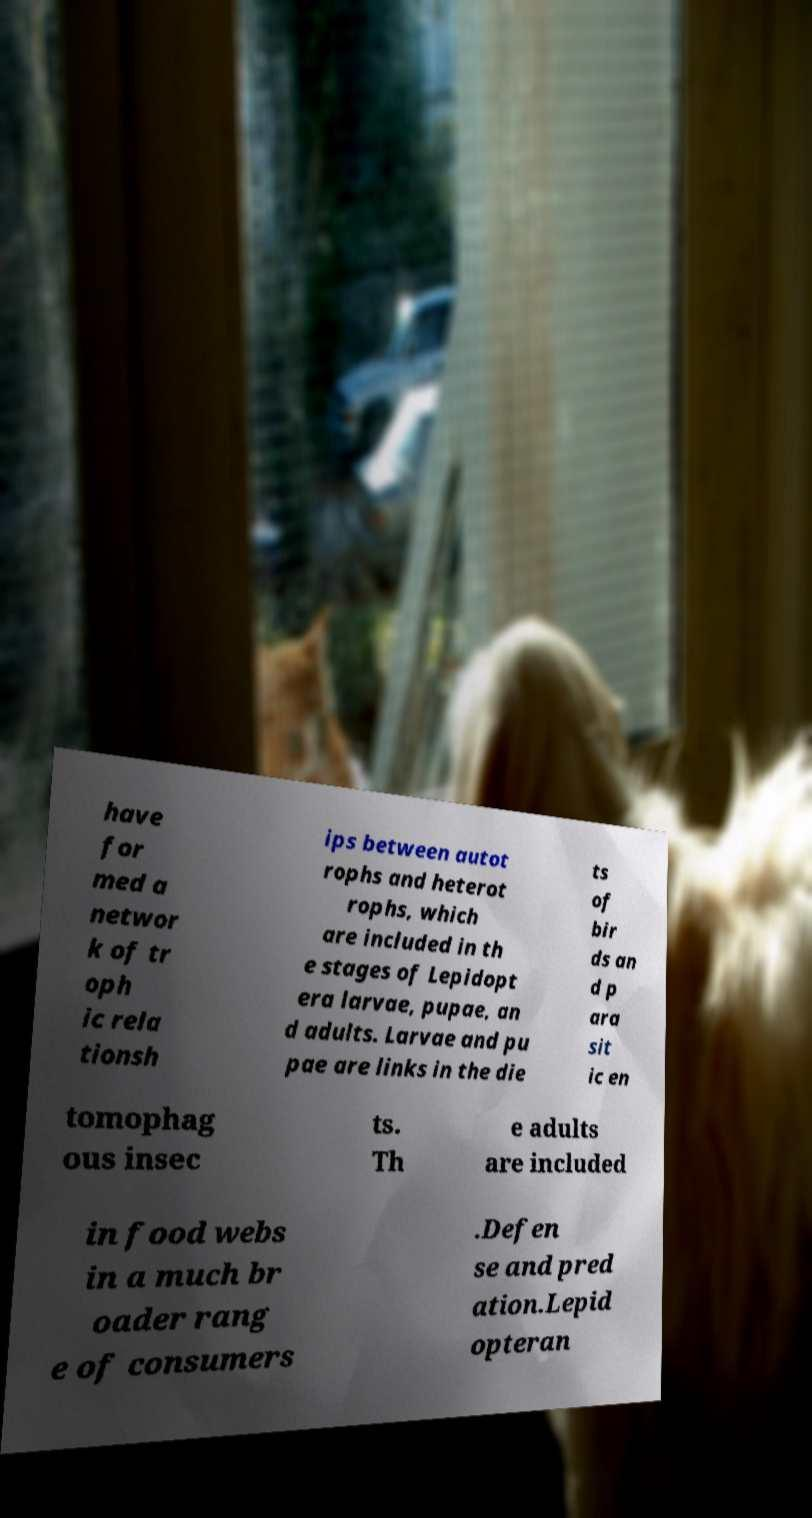For documentation purposes, I need the text within this image transcribed. Could you provide that? have for med a networ k of tr oph ic rela tionsh ips between autot rophs and heterot rophs, which are included in th e stages of Lepidopt era larvae, pupae, an d adults. Larvae and pu pae are links in the die ts of bir ds an d p ara sit ic en tomophag ous insec ts. Th e adults are included in food webs in a much br oader rang e of consumers .Defen se and pred ation.Lepid opteran 